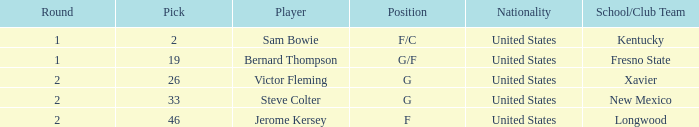What is the highest Pick, when Position is "G/F"? 19.0. 